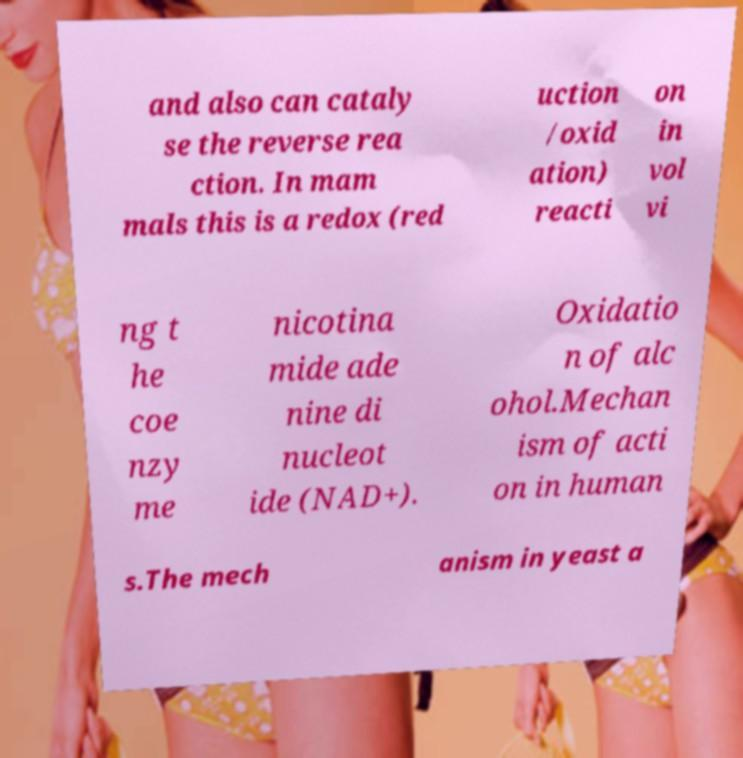What messages or text are displayed in this image? I need them in a readable, typed format. and also can cataly se the reverse rea ction. In mam mals this is a redox (red uction /oxid ation) reacti on in vol vi ng t he coe nzy me nicotina mide ade nine di nucleot ide (NAD+). Oxidatio n of alc ohol.Mechan ism of acti on in human s.The mech anism in yeast a 